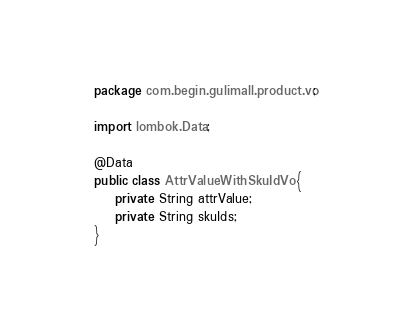Convert code to text. <code><loc_0><loc_0><loc_500><loc_500><_Java_>package com.begin.gulimall.product.vo;

import lombok.Data;

@Data
public class AttrValueWithSkuIdVo {
    private String attrValue;
    private String skuIds;
}
</code> 